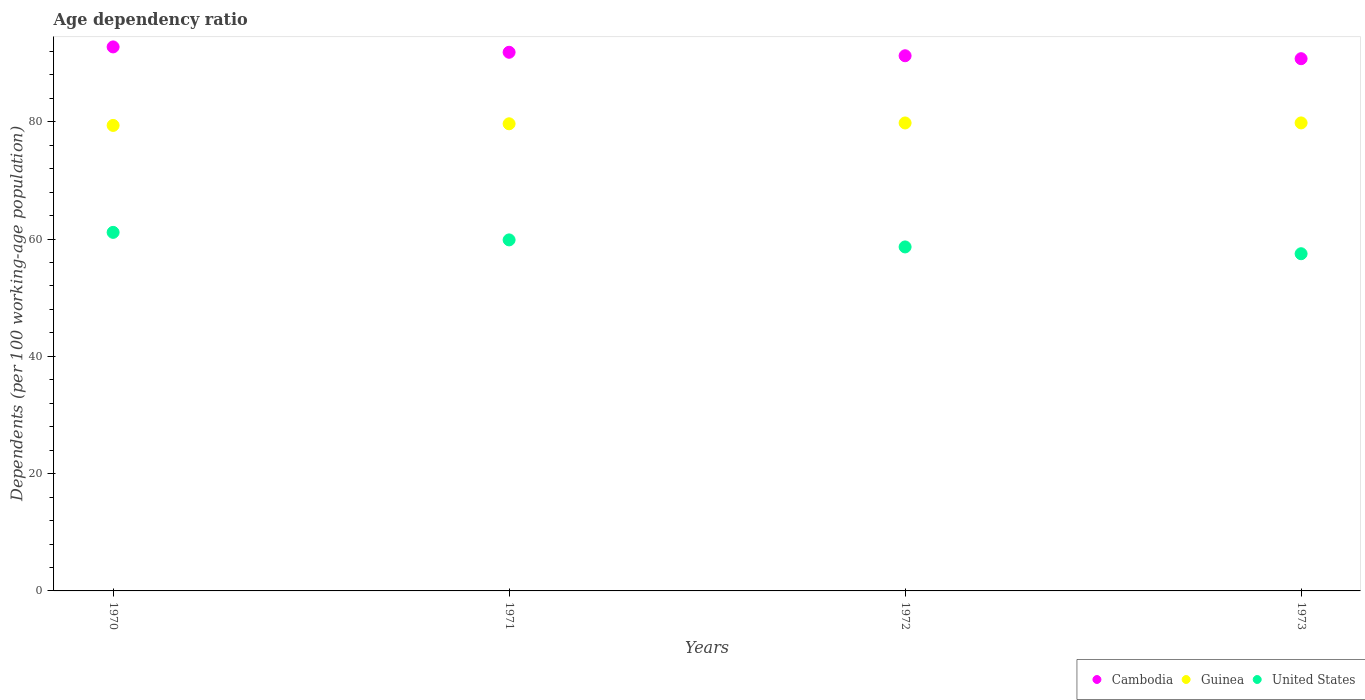What is the age dependency ratio in in Cambodia in 1971?
Offer a very short reply. 91.84. Across all years, what is the maximum age dependency ratio in in Guinea?
Keep it short and to the point. 79.8. Across all years, what is the minimum age dependency ratio in in United States?
Make the answer very short. 57.49. In which year was the age dependency ratio in in Cambodia minimum?
Offer a very short reply. 1973. What is the total age dependency ratio in in Guinea in the graph?
Your answer should be compact. 318.61. What is the difference between the age dependency ratio in in Cambodia in 1972 and that in 1973?
Your answer should be very brief. 0.5. What is the difference between the age dependency ratio in in Cambodia in 1973 and the age dependency ratio in in United States in 1970?
Make the answer very short. 29.61. What is the average age dependency ratio in in Guinea per year?
Your answer should be compact. 79.65. In the year 1972, what is the difference between the age dependency ratio in in Cambodia and age dependency ratio in in Guinea?
Your answer should be compact. 11.46. In how many years, is the age dependency ratio in in United States greater than 20 %?
Offer a terse response. 4. What is the ratio of the age dependency ratio in in Cambodia in 1970 to that in 1972?
Offer a terse response. 1.02. Is the difference between the age dependency ratio in in Cambodia in 1970 and 1972 greater than the difference between the age dependency ratio in in Guinea in 1970 and 1972?
Ensure brevity in your answer.  Yes. What is the difference between the highest and the second highest age dependency ratio in in Cambodia?
Provide a short and direct response. 0.91. What is the difference between the highest and the lowest age dependency ratio in in Guinea?
Your answer should be very brief. 0.43. In how many years, is the age dependency ratio in in Cambodia greater than the average age dependency ratio in in Cambodia taken over all years?
Ensure brevity in your answer.  2. Is the sum of the age dependency ratio in in Cambodia in 1970 and 1971 greater than the maximum age dependency ratio in in Guinea across all years?
Ensure brevity in your answer.  Yes. Is it the case that in every year, the sum of the age dependency ratio in in Cambodia and age dependency ratio in in United States  is greater than the age dependency ratio in in Guinea?
Ensure brevity in your answer.  Yes. Does the age dependency ratio in in United States monotonically increase over the years?
Your response must be concise. No. What is the difference between two consecutive major ticks on the Y-axis?
Your answer should be compact. 20. Are the values on the major ticks of Y-axis written in scientific E-notation?
Provide a short and direct response. No. Does the graph contain grids?
Give a very brief answer. No. How are the legend labels stacked?
Give a very brief answer. Horizontal. What is the title of the graph?
Provide a succinct answer. Age dependency ratio. What is the label or title of the X-axis?
Provide a succinct answer. Years. What is the label or title of the Y-axis?
Give a very brief answer. Dependents (per 100 working-age population). What is the Dependents (per 100 working-age population) in Cambodia in 1970?
Your answer should be compact. 92.76. What is the Dependents (per 100 working-age population) in Guinea in 1970?
Give a very brief answer. 79.37. What is the Dependents (per 100 working-age population) of United States in 1970?
Make the answer very short. 61.14. What is the Dependents (per 100 working-age population) of Cambodia in 1971?
Your response must be concise. 91.84. What is the Dependents (per 100 working-age population) of Guinea in 1971?
Offer a terse response. 79.65. What is the Dependents (per 100 working-age population) of United States in 1971?
Offer a very short reply. 59.85. What is the Dependents (per 100 working-age population) of Cambodia in 1972?
Offer a very short reply. 91.25. What is the Dependents (per 100 working-age population) of Guinea in 1972?
Make the answer very short. 79.79. What is the Dependents (per 100 working-age population) of United States in 1972?
Give a very brief answer. 58.65. What is the Dependents (per 100 working-age population) of Cambodia in 1973?
Offer a terse response. 90.75. What is the Dependents (per 100 working-age population) in Guinea in 1973?
Offer a very short reply. 79.8. What is the Dependents (per 100 working-age population) in United States in 1973?
Make the answer very short. 57.49. Across all years, what is the maximum Dependents (per 100 working-age population) of Cambodia?
Your answer should be very brief. 92.76. Across all years, what is the maximum Dependents (per 100 working-age population) of Guinea?
Keep it short and to the point. 79.8. Across all years, what is the maximum Dependents (per 100 working-age population) in United States?
Provide a short and direct response. 61.14. Across all years, what is the minimum Dependents (per 100 working-age population) of Cambodia?
Your answer should be compact. 90.75. Across all years, what is the minimum Dependents (per 100 working-age population) in Guinea?
Offer a very short reply. 79.37. Across all years, what is the minimum Dependents (per 100 working-age population) of United States?
Ensure brevity in your answer.  57.49. What is the total Dependents (per 100 working-age population) in Cambodia in the graph?
Your response must be concise. 366.6. What is the total Dependents (per 100 working-age population) of Guinea in the graph?
Offer a terse response. 318.61. What is the total Dependents (per 100 working-age population) of United States in the graph?
Offer a terse response. 237.14. What is the difference between the Dependents (per 100 working-age population) in Cambodia in 1970 and that in 1971?
Provide a succinct answer. 0.91. What is the difference between the Dependents (per 100 working-age population) in Guinea in 1970 and that in 1971?
Offer a very short reply. -0.28. What is the difference between the Dependents (per 100 working-age population) of United States in 1970 and that in 1971?
Make the answer very short. 1.28. What is the difference between the Dependents (per 100 working-age population) in Cambodia in 1970 and that in 1972?
Offer a very short reply. 1.51. What is the difference between the Dependents (per 100 working-age population) in Guinea in 1970 and that in 1972?
Provide a succinct answer. -0.42. What is the difference between the Dependents (per 100 working-age population) in United States in 1970 and that in 1972?
Offer a terse response. 2.48. What is the difference between the Dependents (per 100 working-age population) in Cambodia in 1970 and that in 1973?
Your response must be concise. 2.01. What is the difference between the Dependents (per 100 working-age population) of Guinea in 1970 and that in 1973?
Your response must be concise. -0.43. What is the difference between the Dependents (per 100 working-age population) in United States in 1970 and that in 1973?
Provide a succinct answer. 3.64. What is the difference between the Dependents (per 100 working-age population) of Cambodia in 1971 and that in 1972?
Keep it short and to the point. 0.59. What is the difference between the Dependents (per 100 working-age population) in Guinea in 1971 and that in 1972?
Provide a succinct answer. -0.14. What is the difference between the Dependents (per 100 working-age population) in United States in 1971 and that in 1972?
Your response must be concise. 1.2. What is the difference between the Dependents (per 100 working-age population) in Cambodia in 1971 and that in 1973?
Keep it short and to the point. 1.1. What is the difference between the Dependents (per 100 working-age population) in Guinea in 1971 and that in 1973?
Keep it short and to the point. -0.15. What is the difference between the Dependents (per 100 working-age population) in United States in 1971 and that in 1973?
Your answer should be very brief. 2.36. What is the difference between the Dependents (per 100 working-age population) of Cambodia in 1972 and that in 1973?
Offer a very short reply. 0.5. What is the difference between the Dependents (per 100 working-age population) in Guinea in 1972 and that in 1973?
Your response must be concise. -0.01. What is the difference between the Dependents (per 100 working-age population) of United States in 1972 and that in 1973?
Your answer should be compact. 1.16. What is the difference between the Dependents (per 100 working-age population) of Cambodia in 1970 and the Dependents (per 100 working-age population) of Guinea in 1971?
Your response must be concise. 13.11. What is the difference between the Dependents (per 100 working-age population) in Cambodia in 1970 and the Dependents (per 100 working-age population) in United States in 1971?
Give a very brief answer. 32.9. What is the difference between the Dependents (per 100 working-age population) in Guinea in 1970 and the Dependents (per 100 working-age population) in United States in 1971?
Give a very brief answer. 19.52. What is the difference between the Dependents (per 100 working-age population) of Cambodia in 1970 and the Dependents (per 100 working-age population) of Guinea in 1972?
Provide a succinct answer. 12.97. What is the difference between the Dependents (per 100 working-age population) in Cambodia in 1970 and the Dependents (per 100 working-age population) in United States in 1972?
Make the answer very short. 34.1. What is the difference between the Dependents (per 100 working-age population) in Guinea in 1970 and the Dependents (per 100 working-age population) in United States in 1972?
Offer a very short reply. 20.72. What is the difference between the Dependents (per 100 working-age population) in Cambodia in 1970 and the Dependents (per 100 working-age population) in Guinea in 1973?
Ensure brevity in your answer.  12.96. What is the difference between the Dependents (per 100 working-age population) of Cambodia in 1970 and the Dependents (per 100 working-age population) of United States in 1973?
Provide a short and direct response. 35.26. What is the difference between the Dependents (per 100 working-age population) in Guinea in 1970 and the Dependents (per 100 working-age population) in United States in 1973?
Provide a succinct answer. 21.88. What is the difference between the Dependents (per 100 working-age population) of Cambodia in 1971 and the Dependents (per 100 working-age population) of Guinea in 1972?
Offer a terse response. 12.05. What is the difference between the Dependents (per 100 working-age population) of Cambodia in 1971 and the Dependents (per 100 working-age population) of United States in 1972?
Offer a very short reply. 33.19. What is the difference between the Dependents (per 100 working-age population) in Guinea in 1971 and the Dependents (per 100 working-age population) in United States in 1972?
Offer a very short reply. 21. What is the difference between the Dependents (per 100 working-age population) in Cambodia in 1971 and the Dependents (per 100 working-age population) in Guinea in 1973?
Your answer should be very brief. 12.05. What is the difference between the Dependents (per 100 working-age population) in Cambodia in 1971 and the Dependents (per 100 working-age population) in United States in 1973?
Make the answer very short. 34.35. What is the difference between the Dependents (per 100 working-age population) of Guinea in 1971 and the Dependents (per 100 working-age population) of United States in 1973?
Keep it short and to the point. 22.16. What is the difference between the Dependents (per 100 working-age population) of Cambodia in 1972 and the Dependents (per 100 working-age population) of Guinea in 1973?
Ensure brevity in your answer.  11.45. What is the difference between the Dependents (per 100 working-age population) in Cambodia in 1972 and the Dependents (per 100 working-age population) in United States in 1973?
Ensure brevity in your answer.  33.76. What is the difference between the Dependents (per 100 working-age population) in Guinea in 1972 and the Dependents (per 100 working-age population) in United States in 1973?
Keep it short and to the point. 22.3. What is the average Dependents (per 100 working-age population) of Cambodia per year?
Your answer should be very brief. 91.65. What is the average Dependents (per 100 working-age population) in Guinea per year?
Ensure brevity in your answer.  79.65. What is the average Dependents (per 100 working-age population) in United States per year?
Your answer should be compact. 59.28. In the year 1970, what is the difference between the Dependents (per 100 working-age population) in Cambodia and Dependents (per 100 working-age population) in Guinea?
Your answer should be compact. 13.39. In the year 1970, what is the difference between the Dependents (per 100 working-age population) in Cambodia and Dependents (per 100 working-age population) in United States?
Ensure brevity in your answer.  31.62. In the year 1970, what is the difference between the Dependents (per 100 working-age population) in Guinea and Dependents (per 100 working-age population) in United States?
Provide a short and direct response. 18.24. In the year 1971, what is the difference between the Dependents (per 100 working-age population) in Cambodia and Dependents (per 100 working-age population) in Guinea?
Your answer should be very brief. 12.19. In the year 1971, what is the difference between the Dependents (per 100 working-age population) of Cambodia and Dependents (per 100 working-age population) of United States?
Make the answer very short. 31.99. In the year 1971, what is the difference between the Dependents (per 100 working-age population) in Guinea and Dependents (per 100 working-age population) in United States?
Keep it short and to the point. 19.8. In the year 1972, what is the difference between the Dependents (per 100 working-age population) of Cambodia and Dependents (per 100 working-age population) of Guinea?
Ensure brevity in your answer.  11.46. In the year 1972, what is the difference between the Dependents (per 100 working-age population) in Cambodia and Dependents (per 100 working-age population) in United States?
Your answer should be very brief. 32.6. In the year 1972, what is the difference between the Dependents (per 100 working-age population) of Guinea and Dependents (per 100 working-age population) of United States?
Offer a very short reply. 21.14. In the year 1973, what is the difference between the Dependents (per 100 working-age population) of Cambodia and Dependents (per 100 working-age population) of Guinea?
Your response must be concise. 10.95. In the year 1973, what is the difference between the Dependents (per 100 working-age population) of Cambodia and Dependents (per 100 working-age population) of United States?
Make the answer very short. 33.25. In the year 1973, what is the difference between the Dependents (per 100 working-age population) of Guinea and Dependents (per 100 working-age population) of United States?
Provide a succinct answer. 22.3. What is the ratio of the Dependents (per 100 working-age population) in Cambodia in 1970 to that in 1971?
Ensure brevity in your answer.  1.01. What is the ratio of the Dependents (per 100 working-age population) of United States in 1970 to that in 1971?
Your response must be concise. 1.02. What is the ratio of the Dependents (per 100 working-age population) of Cambodia in 1970 to that in 1972?
Your answer should be very brief. 1.02. What is the ratio of the Dependents (per 100 working-age population) of United States in 1970 to that in 1972?
Your answer should be compact. 1.04. What is the ratio of the Dependents (per 100 working-age population) in Cambodia in 1970 to that in 1973?
Make the answer very short. 1.02. What is the ratio of the Dependents (per 100 working-age population) of Guinea in 1970 to that in 1973?
Keep it short and to the point. 0.99. What is the ratio of the Dependents (per 100 working-age population) of United States in 1970 to that in 1973?
Ensure brevity in your answer.  1.06. What is the ratio of the Dependents (per 100 working-age population) of Cambodia in 1971 to that in 1972?
Make the answer very short. 1.01. What is the ratio of the Dependents (per 100 working-age population) in United States in 1971 to that in 1972?
Keep it short and to the point. 1.02. What is the ratio of the Dependents (per 100 working-age population) in Cambodia in 1971 to that in 1973?
Give a very brief answer. 1.01. What is the ratio of the Dependents (per 100 working-age population) of United States in 1971 to that in 1973?
Your response must be concise. 1.04. What is the ratio of the Dependents (per 100 working-age population) of United States in 1972 to that in 1973?
Your response must be concise. 1.02. What is the difference between the highest and the second highest Dependents (per 100 working-age population) in Cambodia?
Your response must be concise. 0.91. What is the difference between the highest and the second highest Dependents (per 100 working-age population) in Guinea?
Your answer should be compact. 0.01. What is the difference between the highest and the second highest Dependents (per 100 working-age population) of United States?
Provide a short and direct response. 1.28. What is the difference between the highest and the lowest Dependents (per 100 working-age population) of Cambodia?
Your answer should be very brief. 2.01. What is the difference between the highest and the lowest Dependents (per 100 working-age population) of Guinea?
Offer a very short reply. 0.43. What is the difference between the highest and the lowest Dependents (per 100 working-age population) of United States?
Offer a very short reply. 3.64. 